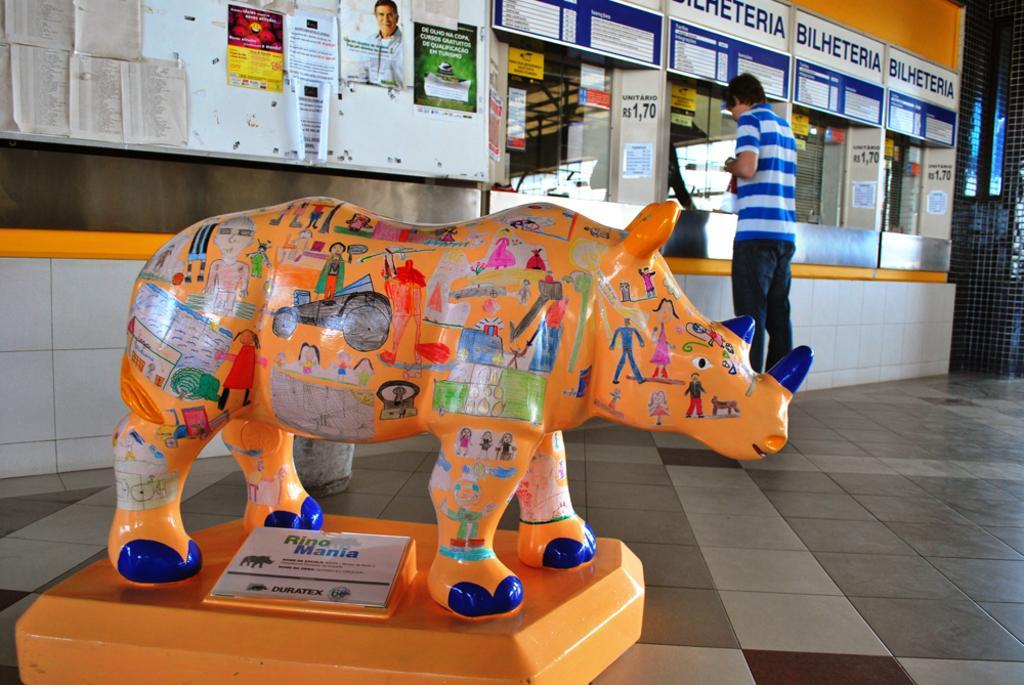In one or two sentences, can you explain what this image depicts? In this image, I can see a person standing on the floor and there are drawings on a toy rhinoceros. I can see a board under a toy rhinoceros. In front of the person, I can see a stall with boards, posters and transparent glasses. In the background, I can see posters and papers to a whiteboard, which is attached to the wall. On the right side of the image, I can see a mesh. 